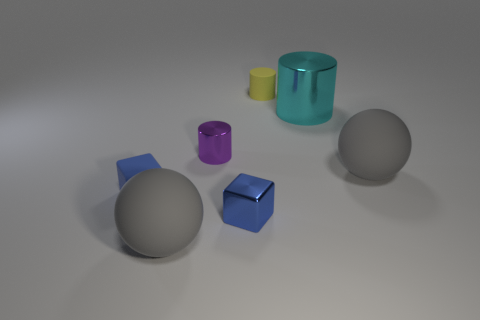Add 3 blue spheres. How many objects exist? 10 Subtract all spheres. How many objects are left? 5 Subtract 0 purple blocks. How many objects are left? 7 Subtract all big gray metal balls. Subtract all purple cylinders. How many objects are left? 6 Add 7 tiny matte things. How many tiny matte things are left? 9 Add 5 yellow blocks. How many yellow blocks exist? 5 